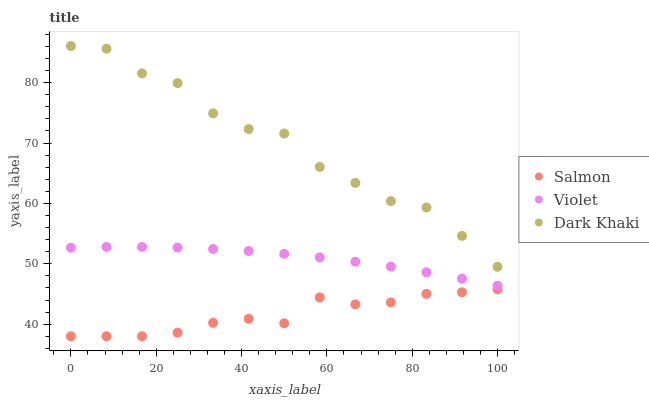Does Salmon have the minimum area under the curve?
Answer yes or no. Yes. Does Dark Khaki have the maximum area under the curve?
Answer yes or no. Yes. Does Violet have the minimum area under the curve?
Answer yes or no. No. Does Violet have the maximum area under the curve?
Answer yes or no. No. Is Violet the smoothest?
Answer yes or no. Yes. Is Dark Khaki the roughest?
Answer yes or no. Yes. Is Salmon the smoothest?
Answer yes or no. No. Is Salmon the roughest?
Answer yes or no. No. Does Salmon have the lowest value?
Answer yes or no. Yes. Does Violet have the lowest value?
Answer yes or no. No. Does Dark Khaki have the highest value?
Answer yes or no. Yes. Does Violet have the highest value?
Answer yes or no. No. Is Salmon less than Dark Khaki?
Answer yes or no. Yes. Is Dark Khaki greater than Salmon?
Answer yes or no. Yes. Does Salmon intersect Dark Khaki?
Answer yes or no. No. 